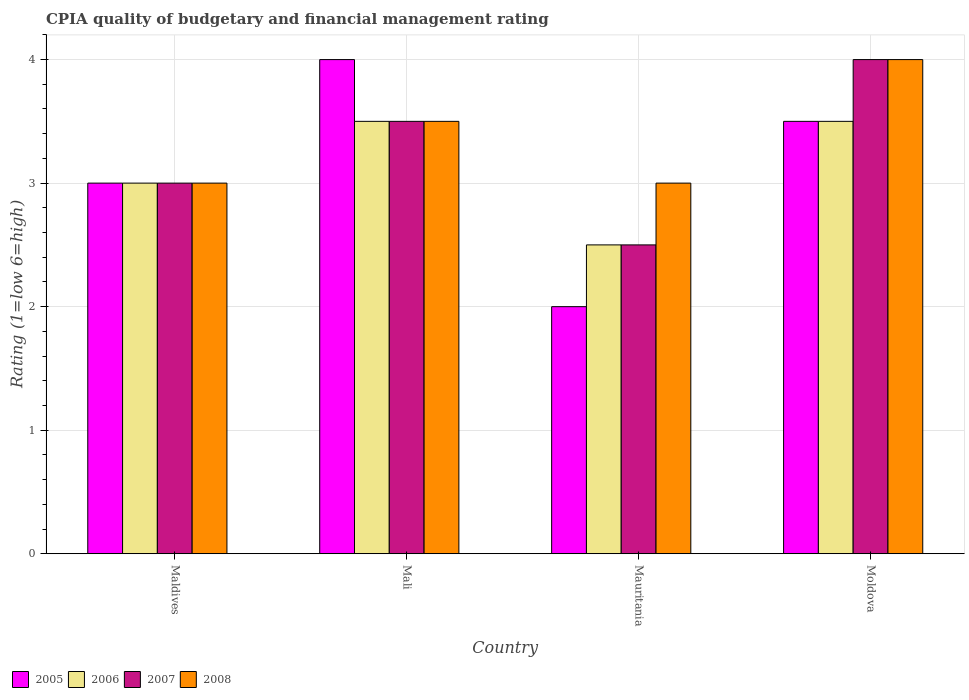How many different coloured bars are there?
Give a very brief answer. 4. Are the number of bars per tick equal to the number of legend labels?
Your answer should be very brief. Yes. Are the number of bars on each tick of the X-axis equal?
Make the answer very short. Yes. What is the label of the 2nd group of bars from the left?
Provide a short and direct response. Mali. What is the CPIA rating in 2006 in Mauritania?
Ensure brevity in your answer.  2.5. Across all countries, what is the minimum CPIA rating in 2008?
Provide a succinct answer. 3. In which country was the CPIA rating in 2005 maximum?
Your answer should be very brief. Mali. In which country was the CPIA rating in 2006 minimum?
Offer a very short reply. Mauritania. What is the total CPIA rating in 2008 in the graph?
Ensure brevity in your answer.  13.5. What is the difference between the CPIA rating in 2008 in Maldives and that in Moldova?
Make the answer very short. -1. What is the difference between the CPIA rating in 2007 in Moldova and the CPIA rating in 2006 in Maldives?
Offer a very short reply. 1. What is the average CPIA rating in 2006 per country?
Offer a terse response. 3.12. What is the ratio of the CPIA rating in 2006 in Mauritania to that in Moldova?
Your answer should be compact. 0.71. Is the CPIA rating in 2008 in Mali less than that in Mauritania?
Keep it short and to the point. No. What is the difference between the highest and the lowest CPIA rating in 2007?
Make the answer very short. 1.5. Is the sum of the CPIA rating in 2006 in Mali and Moldova greater than the maximum CPIA rating in 2007 across all countries?
Provide a succinct answer. Yes. Is it the case that in every country, the sum of the CPIA rating in 2005 and CPIA rating in 2008 is greater than the sum of CPIA rating in 2007 and CPIA rating in 2006?
Your response must be concise. No. What does the 2nd bar from the right in Maldives represents?
Ensure brevity in your answer.  2007. How many bars are there?
Offer a very short reply. 16. How many countries are there in the graph?
Ensure brevity in your answer.  4. What is the difference between two consecutive major ticks on the Y-axis?
Keep it short and to the point. 1. Where does the legend appear in the graph?
Offer a terse response. Bottom left. How many legend labels are there?
Offer a very short reply. 4. What is the title of the graph?
Keep it short and to the point. CPIA quality of budgetary and financial management rating. What is the label or title of the X-axis?
Ensure brevity in your answer.  Country. What is the Rating (1=low 6=high) of 2007 in Maldives?
Keep it short and to the point. 3. What is the Rating (1=low 6=high) in 2005 in Mali?
Your answer should be very brief. 4. What is the Rating (1=low 6=high) of 2007 in Mali?
Provide a succinct answer. 3.5. What is the Rating (1=low 6=high) of 2008 in Mali?
Make the answer very short. 3.5. What is the Rating (1=low 6=high) of 2006 in Mauritania?
Provide a succinct answer. 2.5. What is the Rating (1=low 6=high) of 2007 in Mauritania?
Keep it short and to the point. 2.5. What is the Rating (1=low 6=high) of 2008 in Mauritania?
Your answer should be very brief. 3. What is the Rating (1=low 6=high) in 2005 in Moldova?
Provide a succinct answer. 3.5. What is the Rating (1=low 6=high) in 2008 in Moldova?
Provide a succinct answer. 4. Across all countries, what is the maximum Rating (1=low 6=high) in 2005?
Ensure brevity in your answer.  4. Across all countries, what is the maximum Rating (1=low 6=high) of 2006?
Offer a terse response. 3.5. Across all countries, what is the maximum Rating (1=low 6=high) in 2008?
Offer a terse response. 4. Across all countries, what is the minimum Rating (1=low 6=high) of 2006?
Offer a very short reply. 2.5. Across all countries, what is the minimum Rating (1=low 6=high) of 2007?
Give a very brief answer. 2.5. What is the total Rating (1=low 6=high) in 2005 in the graph?
Your answer should be very brief. 12.5. What is the difference between the Rating (1=low 6=high) of 2008 in Maldives and that in Mali?
Keep it short and to the point. -0.5. What is the difference between the Rating (1=low 6=high) in 2006 in Maldives and that in Moldova?
Your answer should be very brief. -0.5. What is the difference between the Rating (1=low 6=high) of 2008 in Maldives and that in Moldova?
Provide a succinct answer. -1. What is the difference between the Rating (1=low 6=high) of 2007 in Mali and that in Mauritania?
Your answer should be very brief. 1. What is the difference between the Rating (1=low 6=high) in 2008 in Mali and that in Mauritania?
Your answer should be very brief. 0.5. What is the difference between the Rating (1=low 6=high) of 2008 in Mali and that in Moldova?
Keep it short and to the point. -0.5. What is the difference between the Rating (1=low 6=high) in 2007 in Mauritania and that in Moldova?
Make the answer very short. -1.5. What is the difference between the Rating (1=low 6=high) of 2005 in Maldives and the Rating (1=low 6=high) of 2007 in Mali?
Give a very brief answer. -0.5. What is the difference between the Rating (1=low 6=high) in 2005 in Maldives and the Rating (1=low 6=high) in 2008 in Mali?
Provide a succinct answer. -0.5. What is the difference between the Rating (1=low 6=high) in 2006 in Maldives and the Rating (1=low 6=high) in 2007 in Mali?
Offer a terse response. -0.5. What is the difference between the Rating (1=low 6=high) of 2006 in Maldives and the Rating (1=low 6=high) of 2008 in Mali?
Provide a succinct answer. -0.5. What is the difference between the Rating (1=low 6=high) of 2007 in Maldives and the Rating (1=low 6=high) of 2008 in Mali?
Your response must be concise. -0.5. What is the difference between the Rating (1=low 6=high) in 2005 in Maldives and the Rating (1=low 6=high) in 2007 in Mauritania?
Provide a short and direct response. 0.5. What is the difference between the Rating (1=low 6=high) of 2005 in Maldives and the Rating (1=low 6=high) of 2008 in Mauritania?
Offer a terse response. 0. What is the difference between the Rating (1=low 6=high) in 2006 in Maldives and the Rating (1=low 6=high) in 2007 in Mauritania?
Your answer should be compact. 0.5. What is the difference between the Rating (1=low 6=high) in 2006 in Maldives and the Rating (1=low 6=high) in 2008 in Mauritania?
Provide a succinct answer. 0. What is the difference between the Rating (1=low 6=high) in 2007 in Maldives and the Rating (1=low 6=high) in 2008 in Mauritania?
Make the answer very short. 0. What is the difference between the Rating (1=low 6=high) in 2005 in Maldives and the Rating (1=low 6=high) in 2006 in Moldova?
Provide a short and direct response. -0.5. What is the difference between the Rating (1=low 6=high) of 2005 in Maldives and the Rating (1=low 6=high) of 2008 in Moldova?
Provide a succinct answer. -1. What is the difference between the Rating (1=low 6=high) of 2006 in Maldives and the Rating (1=low 6=high) of 2007 in Moldova?
Your answer should be very brief. -1. What is the difference between the Rating (1=low 6=high) in 2006 in Maldives and the Rating (1=low 6=high) in 2008 in Moldova?
Give a very brief answer. -1. What is the difference between the Rating (1=low 6=high) in 2007 in Maldives and the Rating (1=low 6=high) in 2008 in Moldova?
Give a very brief answer. -1. What is the difference between the Rating (1=low 6=high) in 2005 in Mali and the Rating (1=low 6=high) in 2006 in Mauritania?
Keep it short and to the point. 1.5. What is the difference between the Rating (1=low 6=high) in 2005 in Mali and the Rating (1=low 6=high) in 2008 in Mauritania?
Offer a terse response. 1. What is the difference between the Rating (1=low 6=high) of 2007 in Mali and the Rating (1=low 6=high) of 2008 in Mauritania?
Your answer should be very brief. 0.5. What is the difference between the Rating (1=low 6=high) of 2005 in Mali and the Rating (1=low 6=high) of 2008 in Moldova?
Ensure brevity in your answer.  0. What is the difference between the Rating (1=low 6=high) in 2005 in Mauritania and the Rating (1=low 6=high) in 2006 in Moldova?
Your answer should be very brief. -1.5. What is the difference between the Rating (1=low 6=high) of 2005 in Mauritania and the Rating (1=low 6=high) of 2007 in Moldova?
Give a very brief answer. -2. What is the difference between the Rating (1=low 6=high) in 2007 in Mauritania and the Rating (1=low 6=high) in 2008 in Moldova?
Provide a short and direct response. -1.5. What is the average Rating (1=low 6=high) in 2005 per country?
Provide a short and direct response. 3.12. What is the average Rating (1=low 6=high) of 2006 per country?
Give a very brief answer. 3.12. What is the average Rating (1=low 6=high) in 2008 per country?
Provide a succinct answer. 3.38. What is the difference between the Rating (1=low 6=high) of 2005 and Rating (1=low 6=high) of 2007 in Maldives?
Provide a succinct answer. 0. What is the difference between the Rating (1=low 6=high) in 2006 and Rating (1=low 6=high) in 2008 in Maldives?
Provide a succinct answer. 0. What is the difference between the Rating (1=low 6=high) in 2005 and Rating (1=low 6=high) in 2006 in Mali?
Offer a terse response. 0.5. What is the difference between the Rating (1=low 6=high) in 2005 and Rating (1=low 6=high) in 2007 in Mali?
Offer a terse response. 0.5. What is the difference between the Rating (1=low 6=high) in 2005 and Rating (1=low 6=high) in 2006 in Mauritania?
Offer a terse response. -0.5. What is the difference between the Rating (1=low 6=high) in 2005 and Rating (1=low 6=high) in 2008 in Mauritania?
Offer a terse response. -1. What is the difference between the Rating (1=low 6=high) of 2006 and Rating (1=low 6=high) of 2007 in Mauritania?
Provide a succinct answer. 0. What is the difference between the Rating (1=low 6=high) of 2006 and Rating (1=low 6=high) of 2008 in Mauritania?
Your answer should be compact. -0.5. What is the difference between the Rating (1=low 6=high) of 2007 and Rating (1=low 6=high) of 2008 in Mauritania?
Offer a terse response. -0.5. What is the difference between the Rating (1=low 6=high) in 2006 and Rating (1=low 6=high) in 2008 in Moldova?
Offer a terse response. -0.5. What is the ratio of the Rating (1=low 6=high) in 2005 in Maldives to that in Mali?
Make the answer very short. 0.75. What is the ratio of the Rating (1=low 6=high) in 2007 in Maldives to that in Mali?
Provide a succinct answer. 0.86. What is the ratio of the Rating (1=low 6=high) in 2008 in Maldives to that in Mali?
Keep it short and to the point. 0.86. What is the ratio of the Rating (1=low 6=high) in 2005 in Maldives to that in Mauritania?
Offer a terse response. 1.5. What is the ratio of the Rating (1=low 6=high) of 2006 in Maldives to that in Mauritania?
Your response must be concise. 1.2. What is the ratio of the Rating (1=low 6=high) of 2007 in Maldives to that in Mauritania?
Your response must be concise. 1.2. What is the ratio of the Rating (1=low 6=high) of 2008 in Maldives to that in Mauritania?
Your answer should be very brief. 1. What is the ratio of the Rating (1=low 6=high) in 2006 in Maldives to that in Moldova?
Provide a short and direct response. 0.86. What is the ratio of the Rating (1=low 6=high) in 2008 in Maldives to that in Moldova?
Ensure brevity in your answer.  0.75. What is the ratio of the Rating (1=low 6=high) of 2006 in Mali to that in Mauritania?
Provide a succinct answer. 1.4. What is the ratio of the Rating (1=low 6=high) of 2005 in Mali to that in Moldova?
Your response must be concise. 1.14. What is the ratio of the Rating (1=low 6=high) in 2006 in Mali to that in Moldova?
Offer a terse response. 1. What is the ratio of the Rating (1=low 6=high) in 2008 in Mali to that in Moldova?
Give a very brief answer. 0.88. What is the ratio of the Rating (1=low 6=high) in 2007 in Mauritania to that in Moldova?
Your response must be concise. 0.62. What is the ratio of the Rating (1=low 6=high) in 2008 in Mauritania to that in Moldova?
Your answer should be very brief. 0.75. What is the difference between the highest and the second highest Rating (1=low 6=high) in 2005?
Your response must be concise. 0.5. What is the difference between the highest and the second highest Rating (1=low 6=high) in 2006?
Your response must be concise. 0. What is the difference between the highest and the lowest Rating (1=low 6=high) of 2006?
Your response must be concise. 1. 